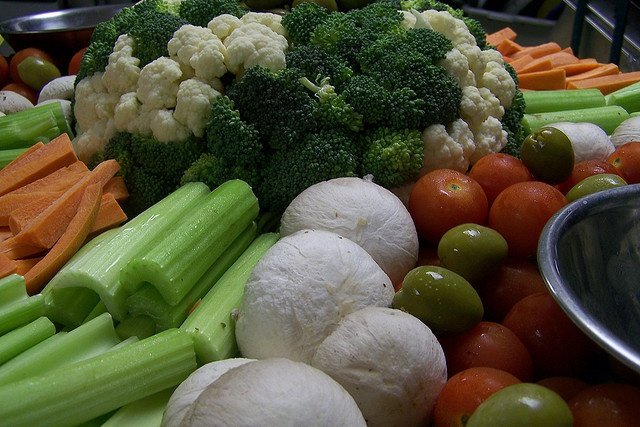Describe the objects in this image and their specific colors. I can see broccoli in black, gray, darkgreen, and darkgray tones, bowl in black and gray tones, carrot in black, brown, and maroon tones, carrot in black, salmon, tan, brown, and maroon tones, and carrot in black, maroon, and brown tones in this image. 